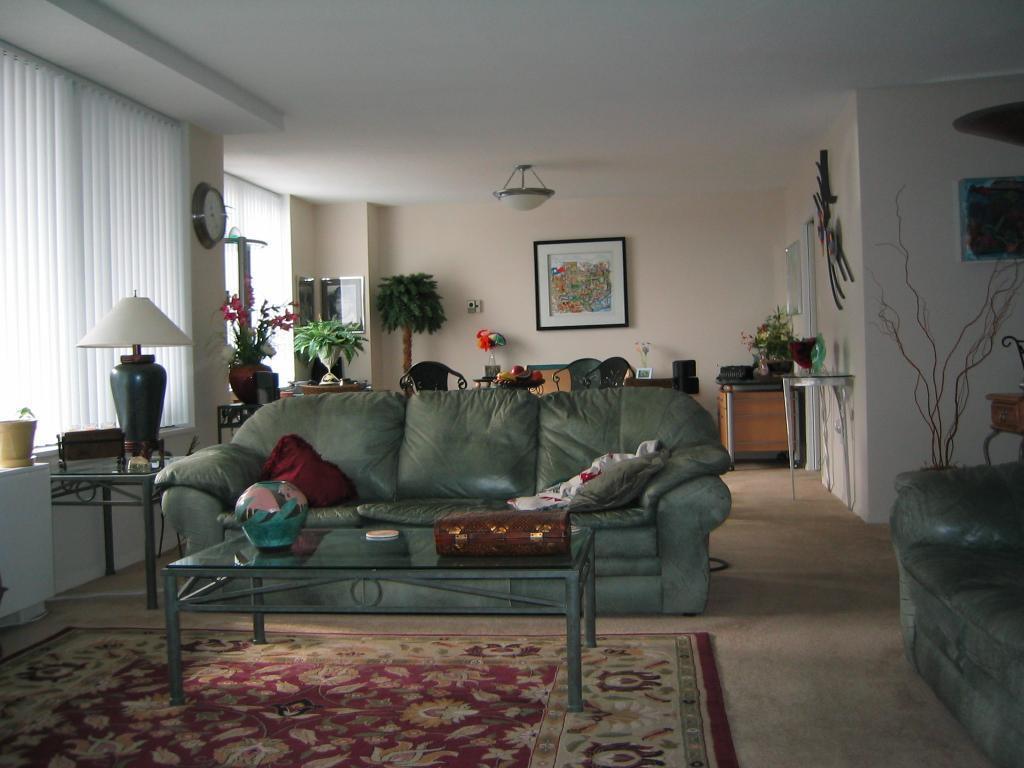Could you give a brief overview of what you see in this image? This is the picture of a place where we have a sofa a desk on which there is a lamp and some frames on the wall. 